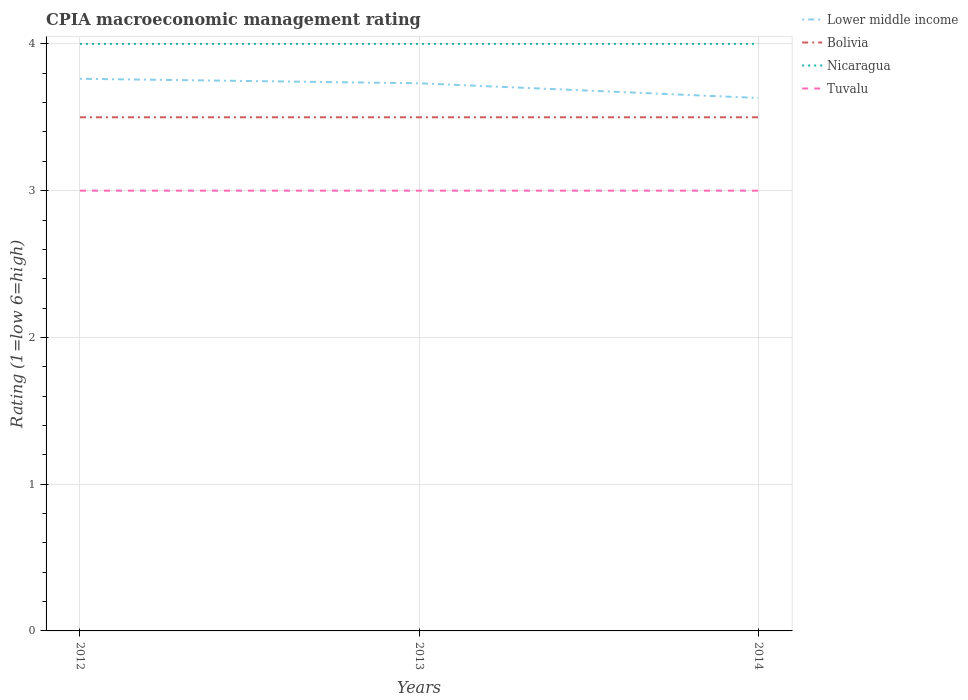Does the line corresponding to Tuvalu intersect with the line corresponding to Bolivia?
Offer a very short reply. No. Is the number of lines equal to the number of legend labels?
Your answer should be compact. Yes. Across all years, what is the maximum CPIA rating in Tuvalu?
Offer a very short reply. 3. In which year was the CPIA rating in Nicaragua maximum?
Make the answer very short. 2012. What is the total CPIA rating in Bolivia in the graph?
Offer a very short reply. 0. What is the difference between the highest and the lowest CPIA rating in Tuvalu?
Offer a terse response. 0. Is the CPIA rating in Bolivia strictly greater than the CPIA rating in Nicaragua over the years?
Ensure brevity in your answer.  Yes. How many lines are there?
Keep it short and to the point. 4. Are the values on the major ticks of Y-axis written in scientific E-notation?
Keep it short and to the point. No. Does the graph contain any zero values?
Your response must be concise. No. Does the graph contain grids?
Make the answer very short. Yes. Where does the legend appear in the graph?
Your answer should be compact. Top right. How many legend labels are there?
Your response must be concise. 4. How are the legend labels stacked?
Keep it short and to the point. Vertical. What is the title of the graph?
Provide a short and direct response. CPIA macroeconomic management rating. What is the Rating (1=low 6=high) of Lower middle income in 2012?
Your answer should be very brief. 3.76. What is the Rating (1=low 6=high) of Bolivia in 2012?
Your response must be concise. 3.5. What is the Rating (1=low 6=high) of Tuvalu in 2012?
Offer a terse response. 3. What is the Rating (1=low 6=high) in Lower middle income in 2013?
Offer a very short reply. 3.73. What is the Rating (1=low 6=high) of Lower middle income in 2014?
Give a very brief answer. 3.63. What is the Rating (1=low 6=high) of Bolivia in 2014?
Keep it short and to the point. 3.5. What is the Rating (1=low 6=high) of Nicaragua in 2014?
Give a very brief answer. 4. What is the Rating (1=low 6=high) of Tuvalu in 2014?
Your answer should be compact. 3. Across all years, what is the maximum Rating (1=low 6=high) in Lower middle income?
Your answer should be compact. 3.76. Across all years, what is the maximum Rating (1=low 6=high) of Bolivia?
Keep it short and to the point. 3.5. Across all years, what is the minimum Rating (1=low 6=high) in Lower middle income?
Ensure brevity in your answer.  3.63. What is the total Rating (1=low 6=high) of Lower middle income in the graph?
Ensure brevity in your answer.  11.13. What is the total Rating (1=low 6=high) in Bolivia in the graph?
Provide a succinct answer. 10.5. What is the total Rating (1=low 6=high) of Nicaragua in the graph?
Offer a very short reply. 12. What is the total Rating (1=low 6=high) of Tuvalu in the graph?
Give a very brief answer. 9. What is the difference between the Rating (1=low 6=high) in Lower middle income in 2012 and that in 2013?
Make the answer very short. 0.03. What is the difference between the Rating (1=low 6=high) in Bolivia in 2012 and that in 2013?
Ensure brevity in your answer.  0. What is the difference between the Rating (1=low 6=high) of Nicaragua in 2012 and that in 2013?
Give a very brief answer. 0. What is the difference between the Rating (1=low 6=high) of Tuvalu in 2012 and that in 2013?
Offer a very short reply. 0. What is the difference between the Rating (1=low 6=high) of Lower middle income in 2012 and that in 2014?
Offer a terse response. 0.13. What is the difference between the Rating (1=low 6=high) of Bolivia in 2012 and that in 2014?
Give a very brief answer. 0. What is the difference between the Rating (1=low 6=high) of Nicaragua in 2012 and that in 2014?
Offer a terse response. 0. What is the difference between the Rating (1=low 6=high) of Tuvalu in 2012 and that in 2014?
Your answer should be compact. 0. What is the difference between the Rating (1=low 6=high) in Lower middle income in 2013 and that in 2014?
Your answer should be very brief. 0.1. What is the difference between the Rating (1=low 6=high) of Bolivia in 2013 and that in 2014?
Provide a short and direct response. 0. What is the difference between the Rating (1=low 6=high) of Tuvalu in 2013 and that in 2014?
Make the answer very short. 0. What is the difference between the Rating (1=low 6=high) of Lower middle income in 2012 and the Rating (1=low 6=high) of Bolivia in 2013?
Provide a short and direct response. 0.26. What is the difference between the Rating (1=low 6=high) of Lower middle income in 2012 and the Rating (1=low 6=high) of Nicaragua in 2013?
Provide a short and direct response. -0.24. What is the difference between the Rating (1=low 6=high) of Lower middle income in 2012 and the Rating (1=low 6=high) of Tuvalu in 2013?
Your response must be concise. 0.76. What is the difference between the Rating (1=low 6=high) of Bolivia in 2012 and the Rating (1=low 6=high) of Nicaragua in 2013?
Keep it short and to the point. -0.5. What is the difference between the Rating (1=low 6=high) of Nicaragua in 2012 and the Rating (1=low 6=high) of Tuvalu in 2013?
Give a very brief answer. 1. What is the difference between the Rating (1=low 6=high) in Lower middle income in 2012 and the Rating (1=low 6=high) in Bolivia in 2014?
Ensure brevity in your answer.  0.26. What is the difference between the Rating (1=low 6=high) in Lower middle income in 2012 and the Rating (1=low 6=high) in Nicaragua in 2014?
Your response must be concise. -0.24. What is the difference between the Rating (1=low 6=high) of Lower middle income in 2012 and the Rating (1=low 6=high) of Tuvalu in 2014?
Provide a short and direct response. 0.76. What is the difference between the Rating (1=low 6=high) of Lower middle income in 2013 and the Rating (1=low 6=high) of Bolivia in 2014?
Your answer should be very brief. 0.23. What is the difference between the Rating (1=low 6=high) in Lower middle income in 2013 and the Rating (1=low 6=high) in Nicaragua in 2014?
Offer a terse response. -0.27. What is the difference between the Rating (1=low 6=high) in Lower middle income in 2013 and the Rating (1=low 6=high) in Tuvalu in 2014?
Make the answer very short. 0.73. What is the difference between the Rating (1=low 6=high) of Bolivia in 2013 and the Rating (1=low 6=high) of Nicaragua in 2014?
Your answer should be very brief. -0.5. What is the difference between the Rating (1=low 6=high) of Bolivia in 2013 and the Rating (1=low 6=high) of Tuvalu in 2014?
Make the answer very short. 0.5. What is the average Rating (1=low 6=high) in Lower middle income per year?
Your answer should be very brief. 3.71. What is the average Rating (1=low 6=high) in Bolivia per year?
Offer a very short reply. 3.5. In the year 2012, what is the difference between the Rating (1=low 6=high) of Lower middle income and Rating (1=low 6=high) of Bolivia?
Your answer should be compact. 0.26. In the year 2012, what is the difference between the Rating (1=low 6=high) of Lower middle income and Rating (1=low 6=high) of Nicaragua?
Offer a very short reply. -0.24. In the year 2012, what is the difference between the Rating (1=low 6=high) in Lower middle income and Rating (1=low 6=high) in Tuvalu?
Ensure brevity in your answer.  0.76. In the year 2013, what is the difference between the Rating (1=low 6=high) in Lower middle income and Rating (1=low 6=high) in Bolivia?
Keep it short and to the point. 0.23. In the year 2013, what is the difference between the Rating (1=low 6=high) in Lower middle income and Rating (1=low 6=high) in Nicaragua?
Make the answer very short. -0.27. In the year 2013, what is the difference between the Rating (1=low 6=high) of Lower middle income and Rating (1=low 6=high) of Tuvalu?
Ensure brevity in your answer.  0.73. In the year 2013, what is the difference between the Rating (1=low 6=high) in Bolivia and Rating (1=low 6=high) in Nicaragua?
Your answer should be compact. -0.5. In the year 2013, what is the difference between the Rating (1=low 6=high) of Bolivia and Rating (1=low 6=high) of Tuvalu?
Provide a succinct answer. 0.5. In the year 2014, what is the difference between the Rating (1=low 6=high) of Lower middle income and Rating (1=low 6=high) of Bolivia?
Your response must be concise. 0.13. In the year 2014, what is the difference between the Rating (1=low 6=high) in Lower middle income and Rating (1=low 6=high) in Nicaragua?
Provide a succinct answer. -0.37. In the year 2014, what is the difference between the Rating (1=low 6=high) of Lower middle income and Rating (1=low 6=high) of Tuvalu?
Keep it short and to the point. 0.63. In the year 2014, what is the difference between the Rating (1=low 6=high) in Bolivia and Rating (1=low 6=high) in Nicaragua?
Make the answer very short. -0.5. In the year 2014, what is the difference between the Rating (1=low 6=high) in Bolivia and Rating (1=low 6=high) in Tuvalu?
Make the answer very short. 0.5. What is the ratio of the Rating (1=low 6=high) in Lower middle income in 2012 to that in 2013?
Keep it short and to the point. 1.01. What is the ratio of the Rating (1=low 6=high) of Nicaragua in 2012 to that in 2013?
Provide a succinct answer. 1. What is the ratio of the Rating (1=low 6=high) in Lower middle income in 2012 to that in 2014?
Offer a very short reply. 1.04. What is the ratio of the Rating (1=low 6=high) in Nicaragua in 2012 to that in 2014?
Ensure brevity in your answer.  1. What is the ratio of the Rating (1=low 6=high) of Tuvalu in 2012 to that in 2014?
Your answer should be compact. 1. What is the ratio of the Rating (1=low 6=high) in Lower middle income in 2013 to that in 2014?
Give a very brief answer. 1.03. What is the ratio of the Rating (1=low 6=high) in Bolivia in 2013 to that in 2014?
Offer a very short reply. 1. What is the difference between the highest and the second highest Rating (1=low 6=high) of Lower middle income?
Provide a succinct answer. 0.03. What is the difference between the highest and the second highest Rating (1=low 6=high) in Bolivia?
Your answer should be compact. 0. What is the difference between the highest and the lowest Rating (1=low 6=high) in Lower middle income?
Your answer should be compact. 0.13. What is the difference between the highest and the lowest Rating (1=low 6=high) in Nicaragua?
Keep it short and to the point. 0. 